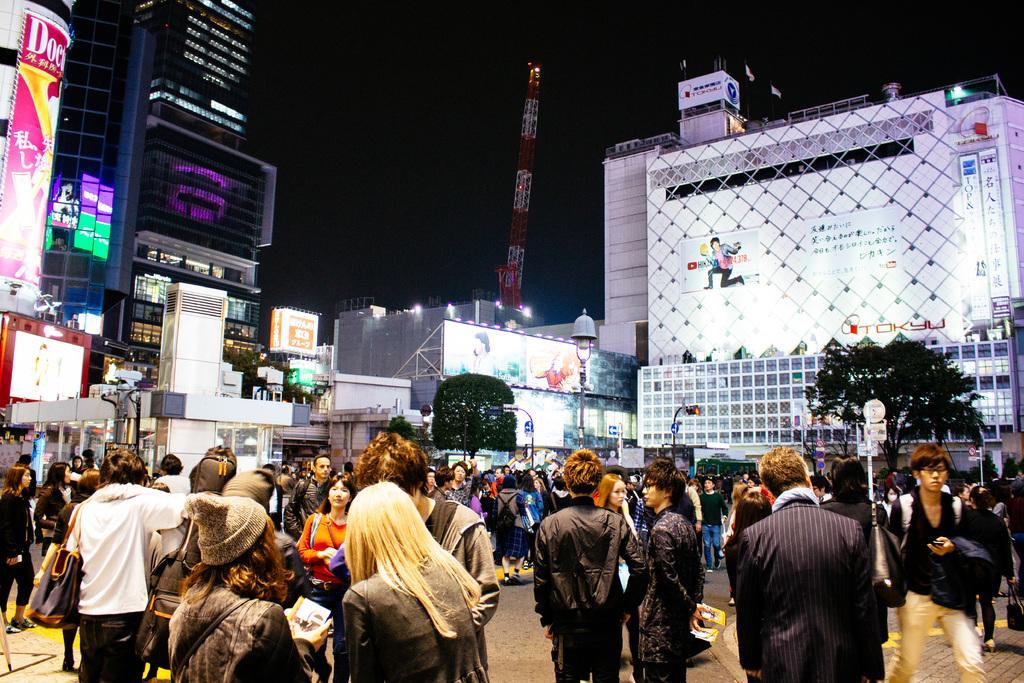How would you summarize this image in a sentence or two? In this image we can see sky scrapers, buildings, advertisement boards, tower, trees, trees, street poles, street lights, stores and people standing on the road. 